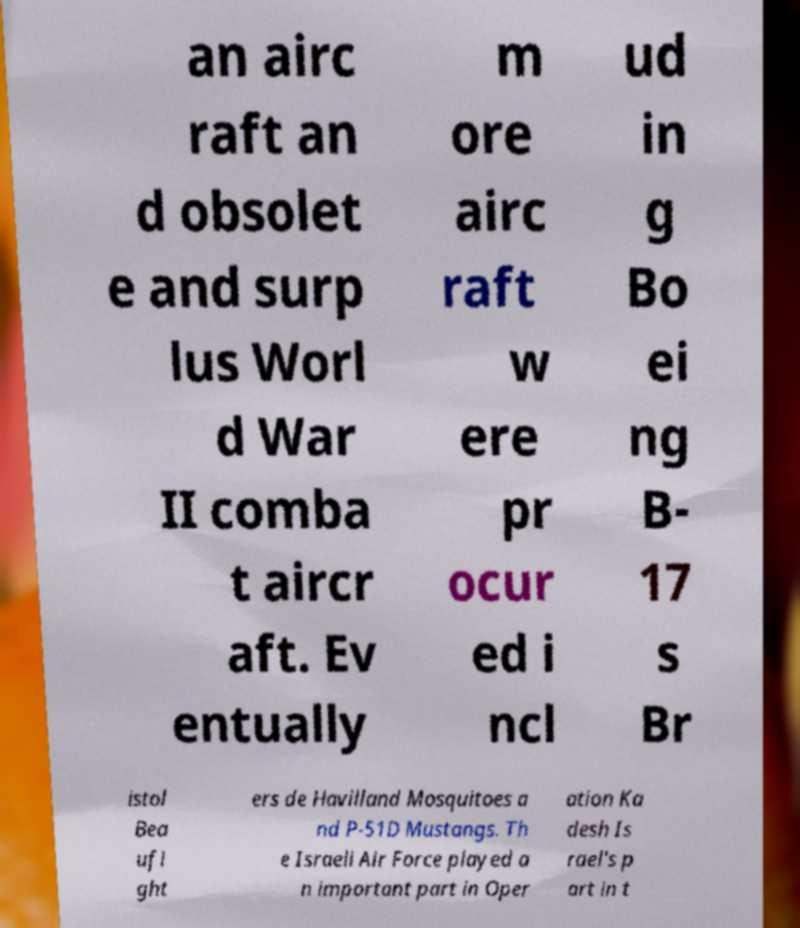I need the written content from this picture converted into text. Can you do that? an airc raft an d obsolet e and surp lus Worl d War II comba t aircr aft. Ev entually m ore airc raft w ere pr ocur ed i ncl ud in g Bo ei ng B- 17 s Br istol Bea ufi ght ers de Havilland Mosquitoes a nd P-51D Mustangs. Th e Israeli Air Force played a n important part in Oper ation Ka desh Is rael's p art in t 